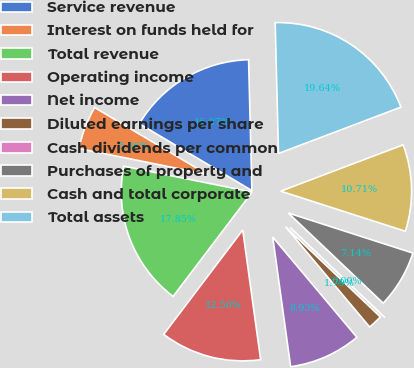<chart> <loc_0><loc_0><loc_500><loc_500><pie_chart><fcel>Service revenue<fcel>Interest on funds held for<fcel>Total revenue<fcel>Operating income<fcel>Net income<fcel>Diluted earnings per share<fcel>Cash dividends per common<fcel>Purchases of property and<fcel>Cash and total corporate<fcel>Total assets<nl><fcel>16.07%<fcel>5.36%<fcel>17.85%<fcel>12.5%<fcel>8.93%<fcel>1.79%<fcel>0.0%<fcel>7.14%<fcel>10.71%<fcel>19.64%<nl></chart> 